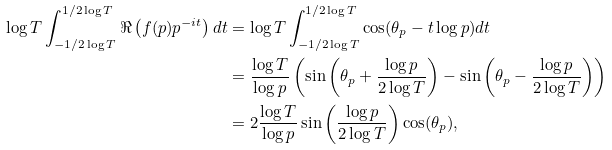<formula> <loc_0><loc_0><loc_500><loc_500>\log T \int _ { - 1 / 2 \log T } ^ { 1 / 2 \log T } \Re \left ( f ( p ) p ^ { - i t } \right ) d t & = \log T \int _ { - 1 / 2 \log T } ^ { 1 / 2 \log T } \cos ( \theta _ { p } - t \log p ) d t \\ & = \frac { \log T } { \log p } \left ( \sin \left ( \theta _ { p } + \frac { \log p } { 2 \log T } \right ) - \sin \left ( \theta _ { p } - \frac { \log p } { 2 \log T } \right ) \right ) \\ & = 2 \frac { \log T } { \log p } \sin \left ( \frac { \log p } { 2 \log T } \right ) \cos ( \theta _ { p } ) ,</formula> 